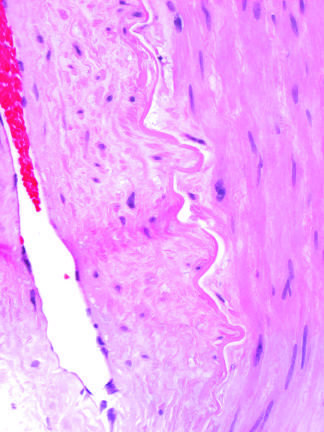s vascular changes and fibrosis of salivary glands produced by radiation therapy of the neck region?
Answer the question using a single word or phrase. Yes 